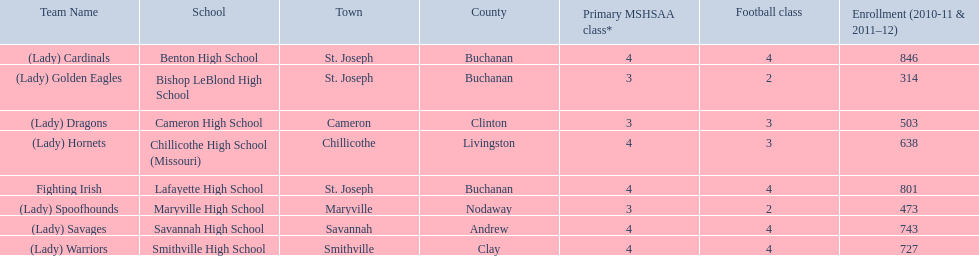What were the schools enrolled in 2010-2011 Benton High School, Bishop LeBlond High School, Cameron High School, Chillicothe High School (Missouri), Lafayette High School, Maryville High School, Savannah High School, Smithville High School. How many were enrolled in each? 846, 314, 503, 638, 801, 473, 743, 727. Which is the lowest number? 314. Which school had this number of students? Bishop LeBlond High School. 